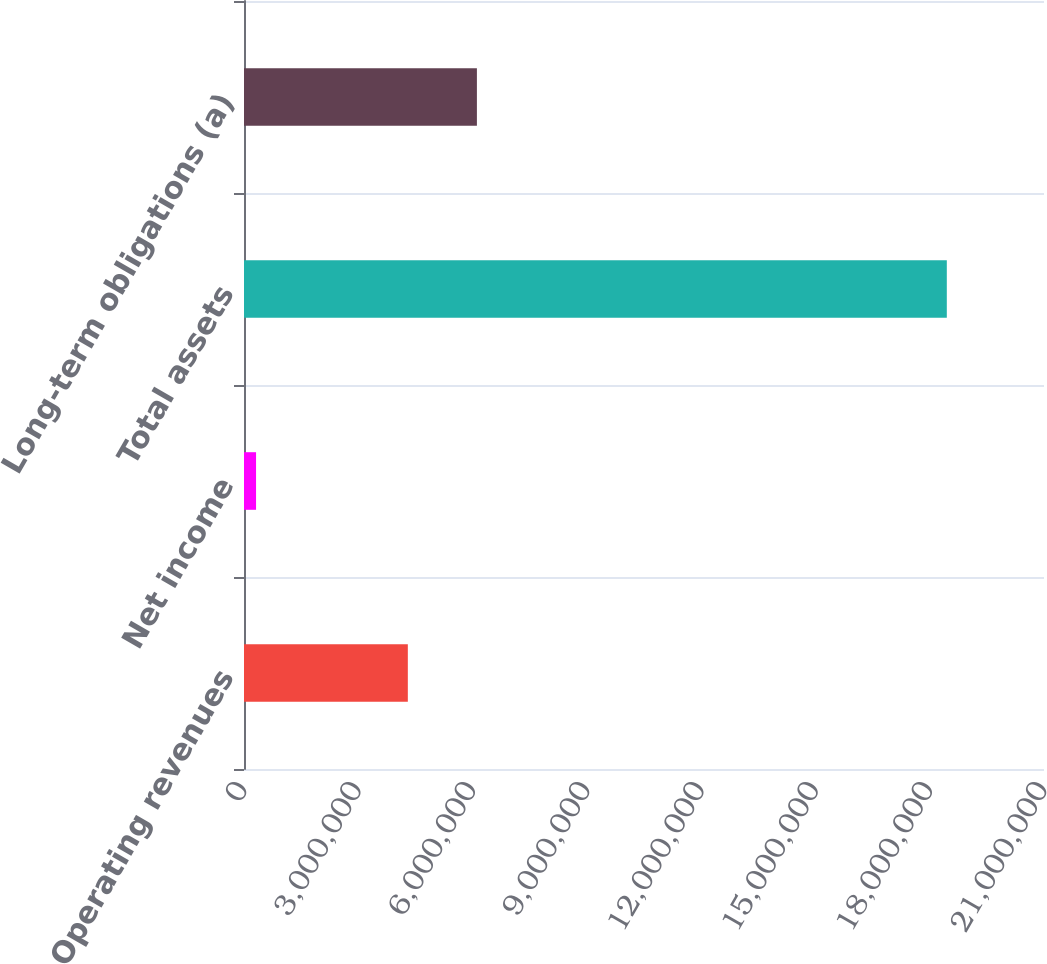<chart> <loc_0><loc_0><loc_500><loc_500><bar_chart><fcel>Operating revenues<fcel>Net income<fcel>Total assets<fcel>Long-term obligations (a)<nl><fcel>4.30055e+06<fcel>316347<fcel>1.84489e+07<fcel>6.1138e+06<nl></chart> 